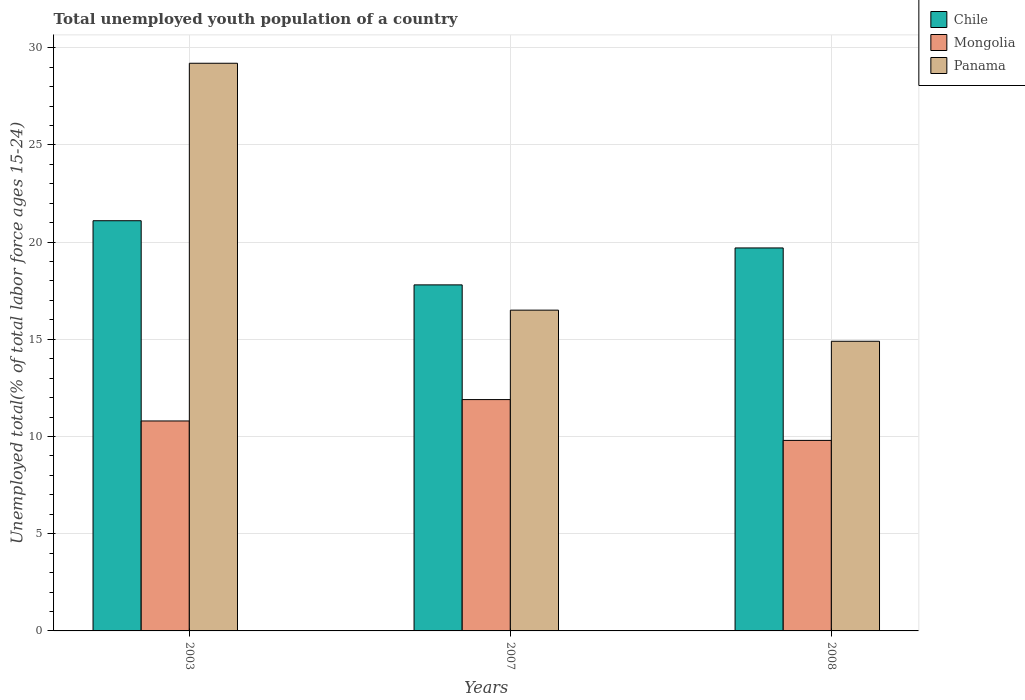How many groups of bars are there?
Provide a short and direct response. 3. Are the number of bars on each tick of the X-axis equal?
Your response must be concise. Yes. How many bars are there on the 3rd tick from the left?
Keep it short and to the point. 3. In how many cases, is the number of bars for a given year not equal to the number of legend labels?
Provide a succinct answer. 0. What is the percentage of total unemployed youth population of a country in Chile in 2003?
Offer a terse response. 21.1. Across all years, what is the maximum percentage of total unemployed youth population of a country in Mongolia?
Provide a short and direct response. 11.9. Across all years, what is the minimum percentage of total unemployed youth population of a country in Panama?
Give a very brief answer. 14.9. In which year was the percentage of total unemployed youth population of a country in Panama maximum?
Keep it short and to the point. 2003. In which year was the percentage of total unemployed youth population of a country in Panama minimum?
Your answer should be compact. 2008. What is the total percentage of total unemployed youth population of a country in Chile in the graph?
Ensure brevity in your answer.  58.6. What is the difference between the percentage of total unemployed youth population of a country in Panama in 2007 and that in 2008?
Offer a very short reply. 1.6. What is the difference between the percentage of total unemployed youth population of a country in Mongolia in 2008 and the percentage of total unemployed youth population of a country in Panama in 2003?
Your answer should be very brief. -19.4. What is the average percentage of total unemployed youth population of a country in Panama per year?
Ensure brevity in your answer.  20.2. In the year 2007, what is the difference between the percentage of total unemployed youth population of a country in Mongolia and percentage of total unemployed youth population of a country in Chile?
Offer a terse response. -5.9. What is the ratio of the percentage of total unemployed youth population of a country in Panama in 2003 to that in 2008?
Offer a terse response. 1.96. Is the difference between the percentage of total unemployed youth population of a country in Mongolia in 2007 and 2008 greater than the difference between the percentage of total unemployed youth population of a country in Chile in 2007 and 2008?
Your response must be concise. Yes. What is the difference between the highest and the second highest percentage of total unemployed youth population of a country in Panama?
Make the answer very short. 12.7. What is the difference between the highest and the lowest percentage of total unemployed youth population of a country in Mongolia?
Make the answer very short. 2.1. Is the sum of the percentage of total unemployed youth population of a country in Chile in 2003 and 2008 greater than the maximum percentage of total unemployed youth population of a country in Mongolia across all years?
Provide a succinct answer. Yes. What does the 2nd bar from the left in 2008 represents?
Provide a succinct answer. Mongolia. What does the 1st bar from the right in 2003 represents?
Offer a terse response. Panama. Is it the case that in every year, the sum of the percentage of total unemployed youth population of a country in Panama and percentage of total unemployed youth population of a country in Chile is greater than the percentage of total unemployed youth population of a country in Mongolia?
Offer a terse response. Yes. How many years are there in the graph?
Offer a very short reply. 3. What is the difference between two consecutive major ticks on the Y-axis?
Offer a terse response. 5. Are the values on the major ticks of Y-axis written in scientific E-notation?
Keep it short and to the point. No. Does the graph contain any zero values?
Ensure brevity in your answer.  No. Does the graph contain grids?
Keep it short and to the point. Yes. How are the legend labels stacked?
Give a very brief answer. Vertical. What is the title of the graph?
Ensure brevity in your answer.  Total unemployed youth population of a country. What is the label or title of the X-axis?
Provide a short and direct response. Years. What is the label or title of the Y-axis?
Keep it short and to the point. Unemployed total(% of total labor force ages 15-24). What is the Unemployed total(% of total labor force ages 15-24) of Chile in 2003?
Provide a short and direct response. 21.1. What is the Unemployed total(% of total labor force ages 15-24) of Mongolia in 2003?
Give a very brief answer. 10.8. What is the Unemployed total(% of total labor force ages 15-24) in Panama in 2003?
Provide a short and direct response. 29.2. What is the Unemployed total(% of total labor force ages 15-24) in Chile in 2007?
Offer a terse response. 17.8. What is the Unemployed total(% of total labor force ages 15-24) in Mongolia in 2007?
Offer a very short reply. 11.9. What is the Unemployed total(% of total labor force ages 15-24) in Chile in 2008?
Offer a very short reply. 19.7. What is the Unemployed total(% of total labor force ages 15-24) in Mongolia in 2008?
Provide a short and direct response. 9.8. What is the Unemployed total(% of total labor force ages 15-24) in Panama in 2008?
Offer a terse response. 14.9. Across all years, what is the maximum Unemployed total(% of total labor force ages 15-24) of Chile?
Keep it short and to the point. 21.1. Across all years, what is the maximum Unemployed total(% of total labor force ages 15-24) in Mongolia?
Your answer should be very brief. 11.9. Across all years, what is the maximum Unemployed total(% of total labor force ages 15-24) of Panama?
Provide a short and direct response. 29.2. Across all years, what is the minimum Unemployed total(% of total labor force ages 15-24) in Chile?
Ensure brevity in your answer.  17.8. Across all years, what is the minimum Unemployed total(% of total labor force ages 15-24) in Mongolia?
Provide a short and direct response. 9.8. Across all years, what is the minimum Unemployed total(% of total labor force ages 15-24) of Panama?
Make the answer very short. 14.9. What is the total Unemployed total(% of total labor force ages 15-24) of Chile in the graph?
Your response must be concise. 58.6. What is the total Unemployed total(% of total labor force ages 15-24) of Mongolia in the graph?
Your answer should be compact. 32.5. What is the total Unemployed total(% of total labor force ages 15-24) of Panama in the graph?
Offer a very short reply. 60.6. What is the difference between the Unemployed total(% of total labor force ages 15-24) of Chile in 2003 and that in 2007?
Your answer should be very brief. 3.3. What is the difference between the Unemployed total(% of total labor force ages 15-24) in Mongolia in 2003 and that in 2007?
Keep it short and to the point. -1.1. What is the difference between the Unemployed total(% of total labor force ages 15-24) of Panama in 2003 and that in 2007?
Give a very brief answer. 12.7. What is the difference between the Unemployed total(% of total labor force ages 15-24) in Mongolia in 2003 and that in 2008?
Provide a succinct answer. 1. What is the difference between the Unemployed total(% of total labor force ages 15-24) of Panama in 2003 and that in 2008?
Your answer should be compact. 14.3. What is the difference between the Unemployed total(% of total labor force ages 15-24) of Chile in 2007 and that in 2008?
Provide a succinct answer. -1.9. What is the difference between the Unemployed total(% of total labor force ages 15-24) of Mongolia in 2007 and that in 2008?
Ensure brevity in your answer.  2.1. What is the difference between the Unemployed total(% of total labor force ages 15-24) in Chile in 2003 and the Unemployed total(% of total labor force ages 15-24) in Mongolia in 2007?
Make the answer very short. 9.2. What is the difference between the Unemployed total(% of total labor force ages 15-24) in Mongolia in 2003 and the Unemployed total(% of total labor force ages 15-24) in Panama in 2007?
Provide a short and direct response. -5.7. What is the difference between the Unemployed total(% of total labor force ages 15-24) of Chile in 2003 and the Unemployed total(% of total labor force ages 15-24) of Mongolia in 2008?
Make the answer very short. 11.3. What is the difference between the Unemployed total(% of total labor force ages 15-24) of Chile in 2003 and the Unemployed total(% of total labor force ages 15-24) of Panama in 2008?
Provide a short and direct response. 6.2. What is the difference between the Unemployed total(% of total labor force ages 15-24) of Mongolia in 2003 and the Unemployed total(% of total labor force ages 15-24) of Panama in 2008?
Ensure brevity in your answer.  -4.1. What is the difference between the Unemployed total(% of total labor force ages 15-24) in Chile in 2007 and the Unemployed total(% of total labor force ages 15-24) in Mongolia in 2008?
Provide a succinct answer. 8. What is the difference between the Unemployed total(% of total labor force ages 15-24) in Chile in 2007 and the Unemployed total(% of total labor force ages 15-24) in Panama in 2008?
Your answer should be compact. 2.9. What is the difference between the Unemployed total(% of total labor force ages 15-24) of Mongolia in 2007 and the Unemployed total(% of total labor force ages 15-24) of Panama in 2008?
Keep it short and to the point. -3. What is the average Unemployed total(% of total labor force ages 15-24) of Chile per year?
Make the answer very short. 19.53. What is the average Unemployed total(% of total labor force ages 15-24) of Mongolia per year?
Your response must be concise. 10.83. What is the average Unemployed total(% of total labor force ages 15-24) of Panama per year?
Keep it short and to the point. 20.2. In the year 2003, what is the difference between the Unemployed total(% of total labor force ages 15-24) of Chile and Unemployed total(% of total labor force ages 15-24) of Mongolia?
Give a very brief answer. 10.3. In the year 2003, what is the difference between the Unemployed total(% of total labor force ages 15-24) of Chile and Unemployed total(% of total labor force ages 15-24) of Panama?
Keep it short and to the point. -8.1. In the year 2003, what is the difference between the Unemployed total(% of total labor force ages 15-24) of Mongolia and Unemployed total(% of total labor force ages 15-24) of Panama?
Offer a terse response. -18.4. In the year 2007, what is the difference between the Unemployed total(% of total labor force ages 15-24) of Chile and Unemployed total(% of total labor force ages 15-24) of Mongolia?
Make the answer very short. 5.9. In the year 2007, what is the difference between the Unemployed total(% of total labor force ages 15-24) in Mongolia and Unemployed total(% of total labor force ages 15-24) in Panama?
Your response must be concise. -4.6. In the year 2008, what is the difference between the Unemployed total(% of total labor force ages 15-24) of Chile and Unemployed total(% of total labor force ages 15-24) of Panama?
Ensure brevity in your answer.  4.8. In the year 2008, what is the difference between the Unemployed total(% of total labor force ages 15-24) in Mongolia and Unemployed total(% of total labor force ages 15-24) in Panama?
Your answer should be compact. -5.1. What is the ratio of the Unemployed total(% of total labor force ages 15-24) of Chile in 2003 to that in 2007?
Ensure brevity in your answer.  1.19. What is the ratio of the Unemployed total(% of total labor force ages 15-24) of Mongolia in 2003 to that in 2007?
Provide a short and direct response. 0.91. What is the ratio of the Unemployed total(% of total labor force ages 15-24) of Panama in 2003 to that in 2007?
Offer a terse response. 1.77. What is the ratio of the Unemployed total(% of total labor force ages 15-24) of Chile in 2003 to that in 2008?
Keep it short and to the point. 1.07. What is the ratio of the Unemployed total(% of total labor force ages 15-24) in Mongolia in 2003 to that in 2008?
Offer a very short reply. 1.1. What is the ratio of the Unemployed total(% of total labor force ages 15-24) in Panama in 2003 to that in 2008?
Provide a succinct answer. 1.96. What is the ratio of the Unemployed total(% of total labor force ages 15-24) of Chile in 2007 to that in 2008?
Keep it short and to the point. 0.9. What is the ratio of the Unemployed total(% of total labor force ages 15-24) in Mongolia in 2007 to that in 2008?
Keep it short and to the point. 1.21. What is the ratio of the Unemployed total(% of total labor force ages 15-24) of Panama in 2007 to that in 2008?
Your answer should be compact. 1.11. What is the difference between the highest and the second highest Unemployed total(% of total labor force ages 15-24) of Chile?
Provide a short and direct response. 1.4. What is the difference between the highest and the lowest Unemployed total(% of total labor force ages 15-24) in Mongolia?
Your response must be concise. 2.1. 